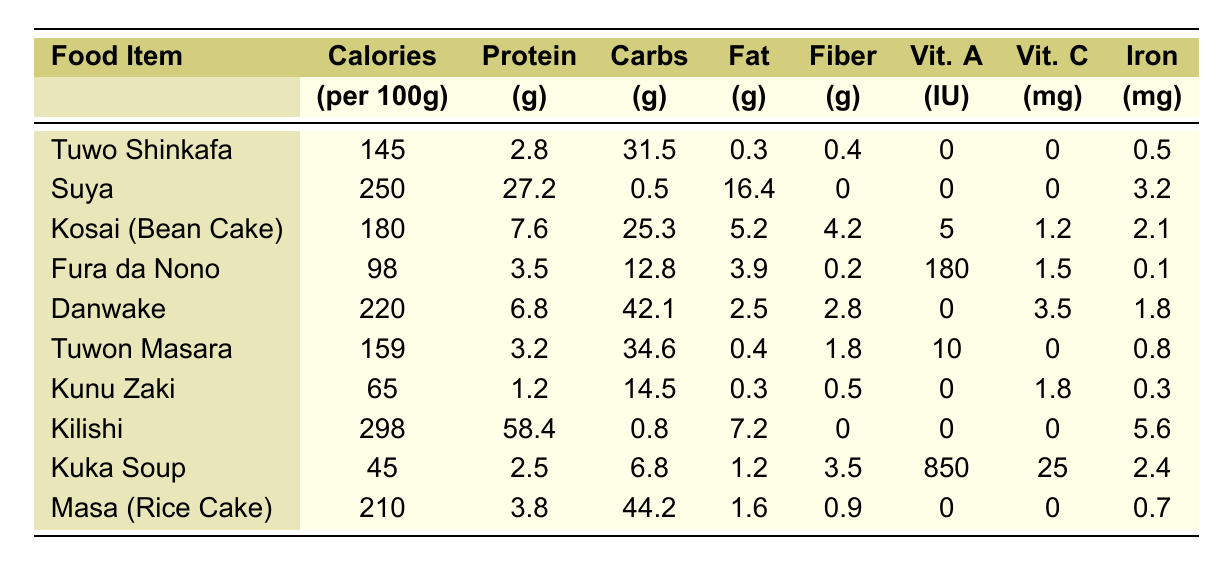What food item has the highest protein content? Kilishi has the highest protein content with 58.4 grams per 100 grams.
Answer: Kilishi Which food item has the least calories? Kuka Soup has the least calories with only 45 calories per 100 grams.
Answer: Kuka Soup What is the total fat content in Danwake and Kosai? Danwake contains 2.5 grams of fat and Kosai contains 5.2 grams. Adding them together gives 2.5 + 5.2 = 7.7 grams of fat.
Answer: 7.7 grams Is the Vitamin C content in Kunu Zaki higher than that in Fura da Nono? Kunu Zaki has 1.8 mg of Vitamin C while Fura da Nono has 1.5 mg. Since 1.8 mg is greater than 1.5 mg, it is true that Kunu Zaki has more Vitamin C.
Answer: Yes What is the range of calories in the food items listed? The highest calorie food is Kilishi with 298 calories, and the lowest is Kuka Soup with 45 calories. The range is 298 - 45 = 253 calories.
Answer: 253 calories Calculate the average protein content of all food items combined. The total protein content from all items is 2.8 + 27.2 + 7.6 + 3.5 + 6.8 + 3.2 + 1.2 + 58.4 + 2.5 + 3.8 = 115.0 grams. There are 10 items, so the average protein content is 115.0 / 10 = 11.5 grams.
Answer: 11.5 grams Which food item has more fat, Suya or Masa? Suya has 16.4 grams of fat and Masa has 1.6 grams. Comparing the two, 16.4 is greater than 1.6, so Suya has more fat.
Answer: Suya Does Fura da Nono provide more Vitamin A than Tuwon Masara? Fura da Nono provides 180 IU of Vitamin A while Tuwon Masara provides 10 IU. Since 180 IU is greater than 10 IU, it is true that Fura da Nono provides more Vitamin A.
Answer: Yes What is the total carbohydrate content of Tuwo Shinkafa and Masa? Tuwo Shinkafa has 31.5 grams of carbohydrates and Masa has 44.2 grams. Adding them gives 31.5 + 44.2 = 75.7 grams of carbohydrates.
Answer: 75.7 grams Which food item is the best source of Iron? Kilishi has the highest Iron content with 5.6 mg per 100 grams.
Answer: Kilishi 